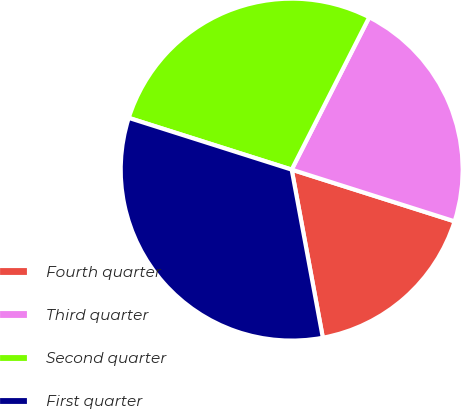<chart> <loc_0><loc_0><loc_500><loc_500><pie_chart><fcel>Fourth quarter<fcel>Third quarter<fcel>Second quarter<fcel>First quarter<nl><fcel>17.19%<fcel>22.4%<fcel>27.6%<fcel>32.81%<nl></chart> 